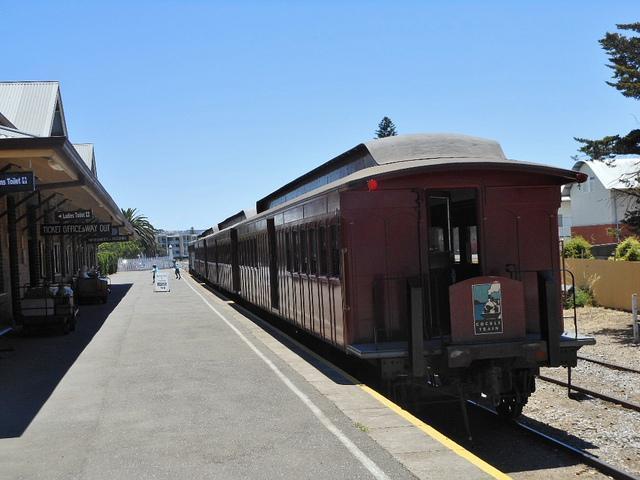What might the red light mean?
Select the accurate answer and provide explanation: 'Answer: answer
Rationale: rationale.'
Options: Ready, loading, unavailable, stop. Answer: unavailable.
Rationale: It shows that there might be a problem and it is not available. 